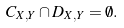Convert formula to latex. <formula><loc_0><loc_0><loc_500><loc_500>C _ { X , Y } \cap D _ { X , Y } = \emptyset .</formula> 